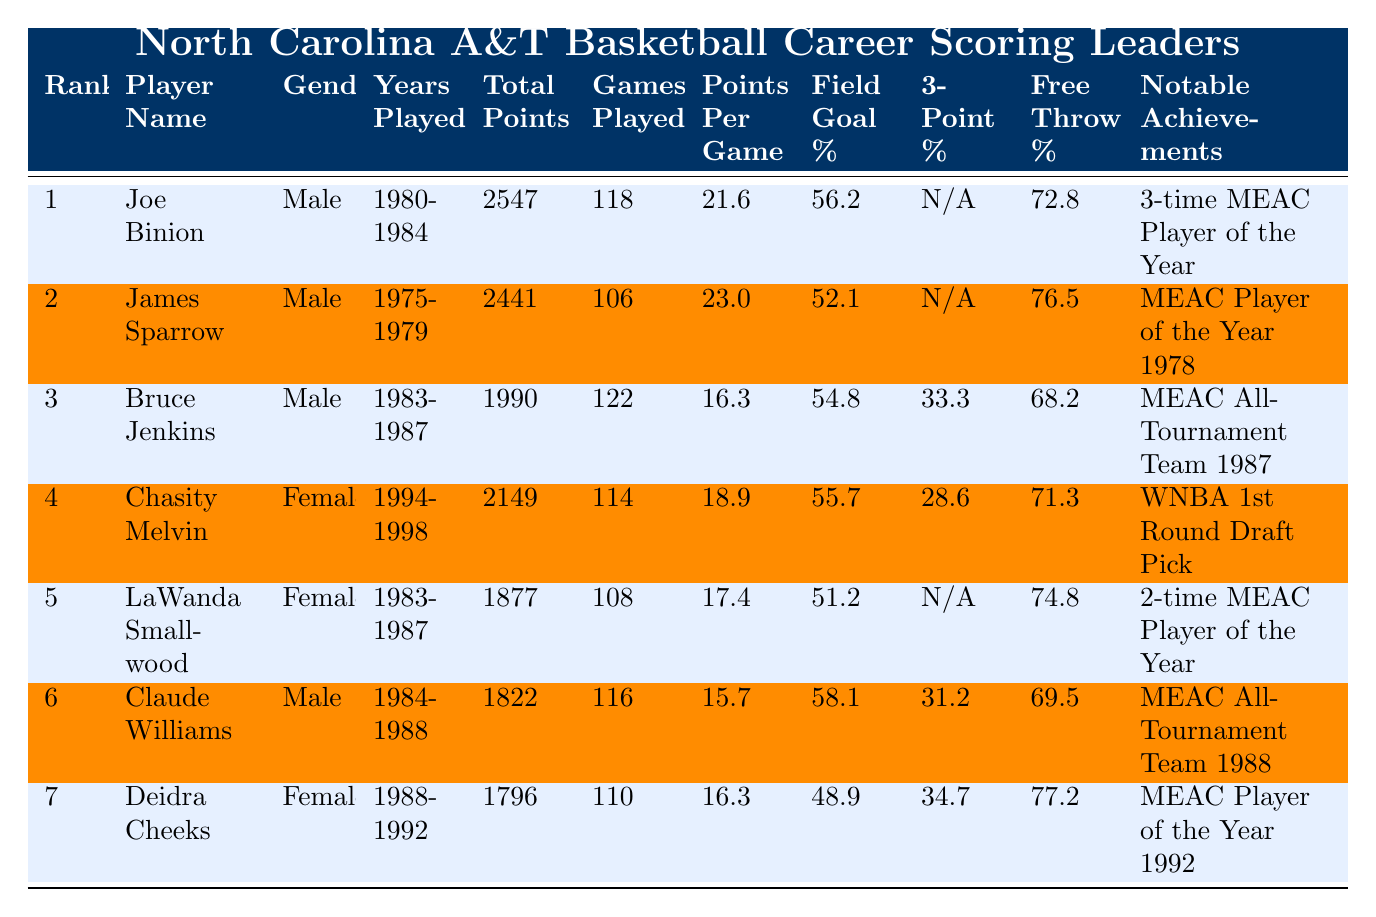What is the total points scored by Joe Binion? According to the table, Joe Binion scored a total of 2547 points.
Answer: 2547 Who has the highest points per game average among male players? By checking the "Points Per Game" column for male players, James Sparrow has the highest average at 23.0 points per game.
Answer: 23.0 Which female player has the highest total points scored? Looking at the "Total Points" column for female players, Chasity Melvin scored the highest with 2149 points.
Answer: 2149 True or False: Deidra Cheeks has a better field goal percentage than LaWanda Smallwood. Deidra Cheeks has a field goal percentage of 48.9%, while LaWanda Smallwood has 51.2%. Since 48.9% is less than 51.2%, the statement is false.
Answer: False What is the average total points scored by male players in the table? The total points for male players are 2547 (Joe Binion) + 2441 (James Sparrow) + 1990 (Bruce Jenkins) + 1822 (Claude Williams) = 9780. There are 4 male players, so the average is 9780 / 4 = 2445.
Answer: 2445 Which player's achievements include being a 1st round draft pick? According to the "Notable Achievements" column, Chasity Melvin is noted as a "WNBA 1st Round Draft Pick."
Answer: Chasity Melvin What is the difference in total points between the highest and second highest male scorer? The highest male scorer is Joe Binion with 2547 points, and the second highest is James Sparrow with 2441 points. The difference is 2547 - 2441 = 106.
Answer: 106 Which player has the highest free throw percentage? Reviewing the "Free Throw %" column, Deidra Cheeks has the highest free throw percentage at 77.2%.
Answer: 77.2 What percentage of games did Joe Binion win based on his total points and games played average? Joe Binion scored 2547 points over 118 games, meaning he averaged 21.6 points per game. Without win-loss data in the table, the win percentage cannot be calculated from the provided information.
Answer: Insufficient data to answer Identify the player with a 3-point shooting percentage listed as "N/A." The players with a 3-point shooting percentage listed as "N/A" are Joe Binion and LaWanda Smallwood.
Answer: Joe Binion and LaWanda Smallwood 